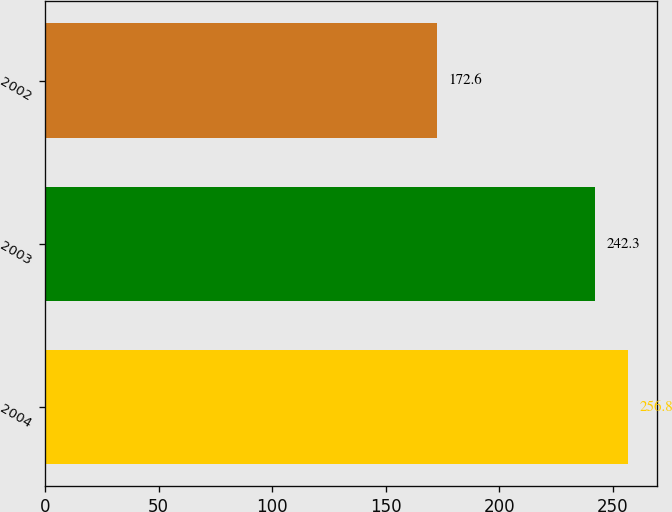Convert chart to OTSL. <chart><loc_0><loc_0><loc_500><loc_500><bar_chart><fcel>2004<fcel>2003<fcel>2002<nl><fcel>256.8<fcel>242.3<fcel>172.6<nl></chart> 